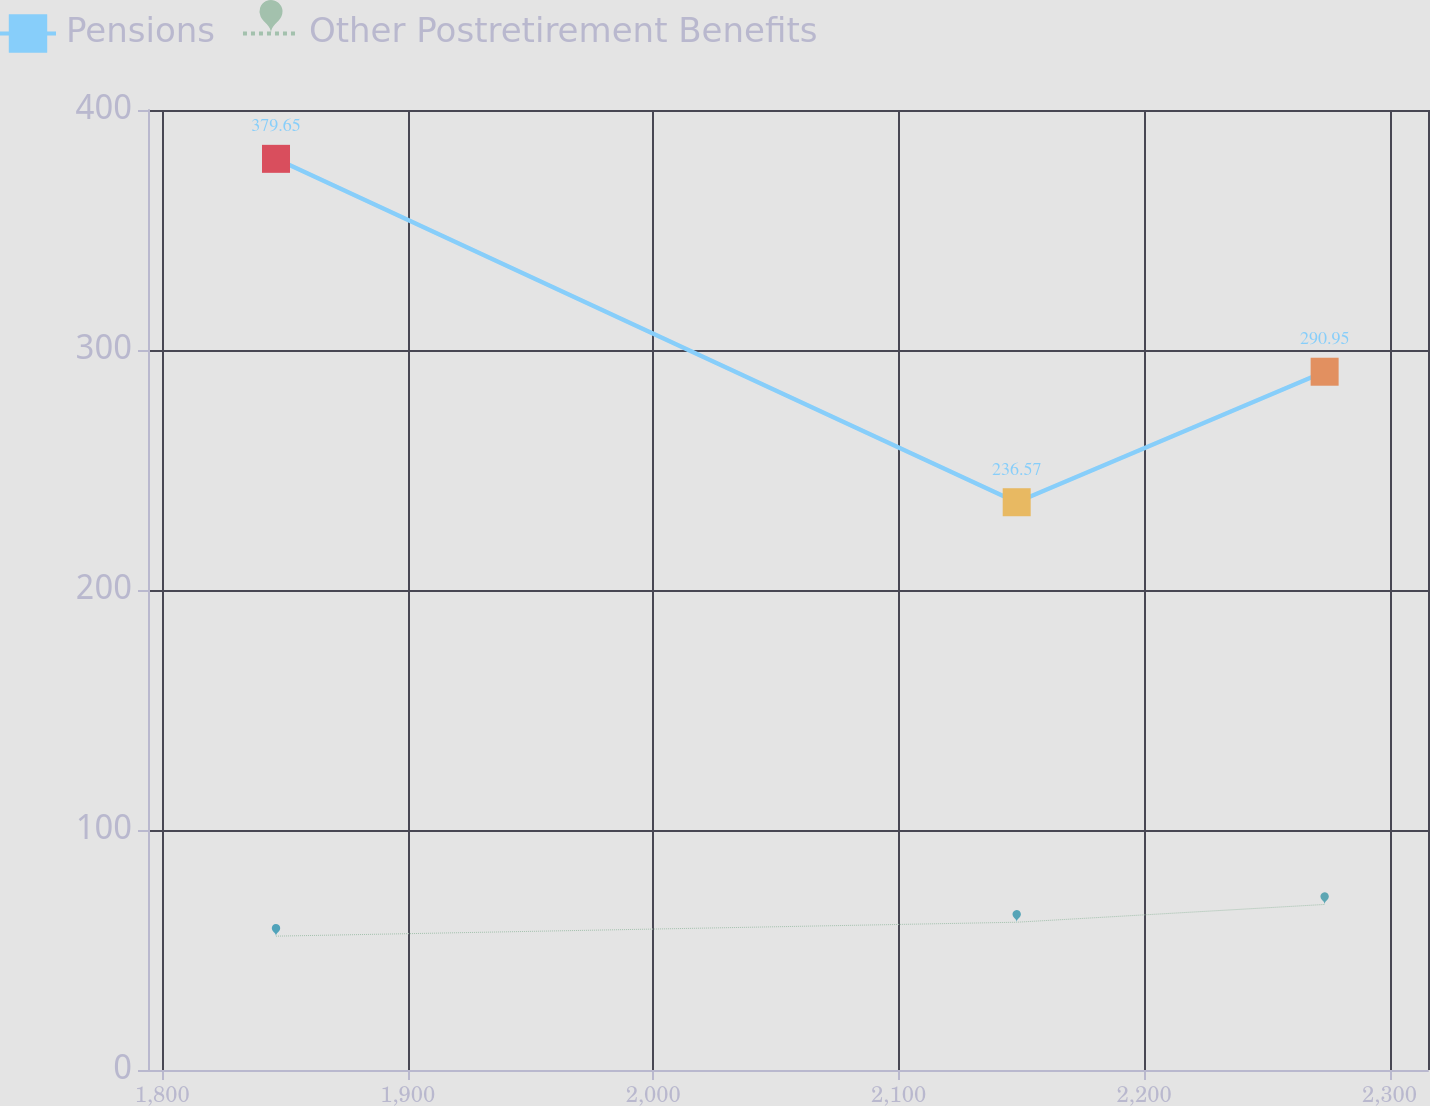Convert chart to OTSL. <chart><loc_0><loc_0><loc_500><loc_500><line_chart><ecel><fcel>Pensions<fcel>Other Postretirement Benefits<nl><fcel>1846.34<fcel>379.65<fcel>55.77<nl><fcel>2148.1<fcel>236.57<fcel>61.57<nl><fcel>2273.55<fcel>290.95<fcel>68.98<nl><fcel>2320.68<fcel>332.58<fcel>67.23<nl><fcel>2367.81<fcel>276.64<fcel>59.88<nl></chart> 